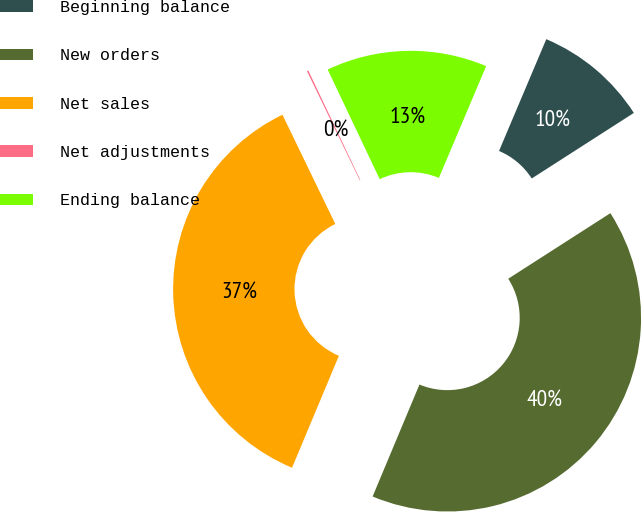<chart> <loc_0><loc_0><loc_500><loc_500><pie_chart><fcel>Beginning balance<fcel>New orders<fcel>Net sales<fcel>Net adjustments<fcel>Ending balance<nl><fcel>9.55%<fcel>40.39%<fcel>36.52%<fcel>0.12%<fcel>13.42%<nl></chart> 